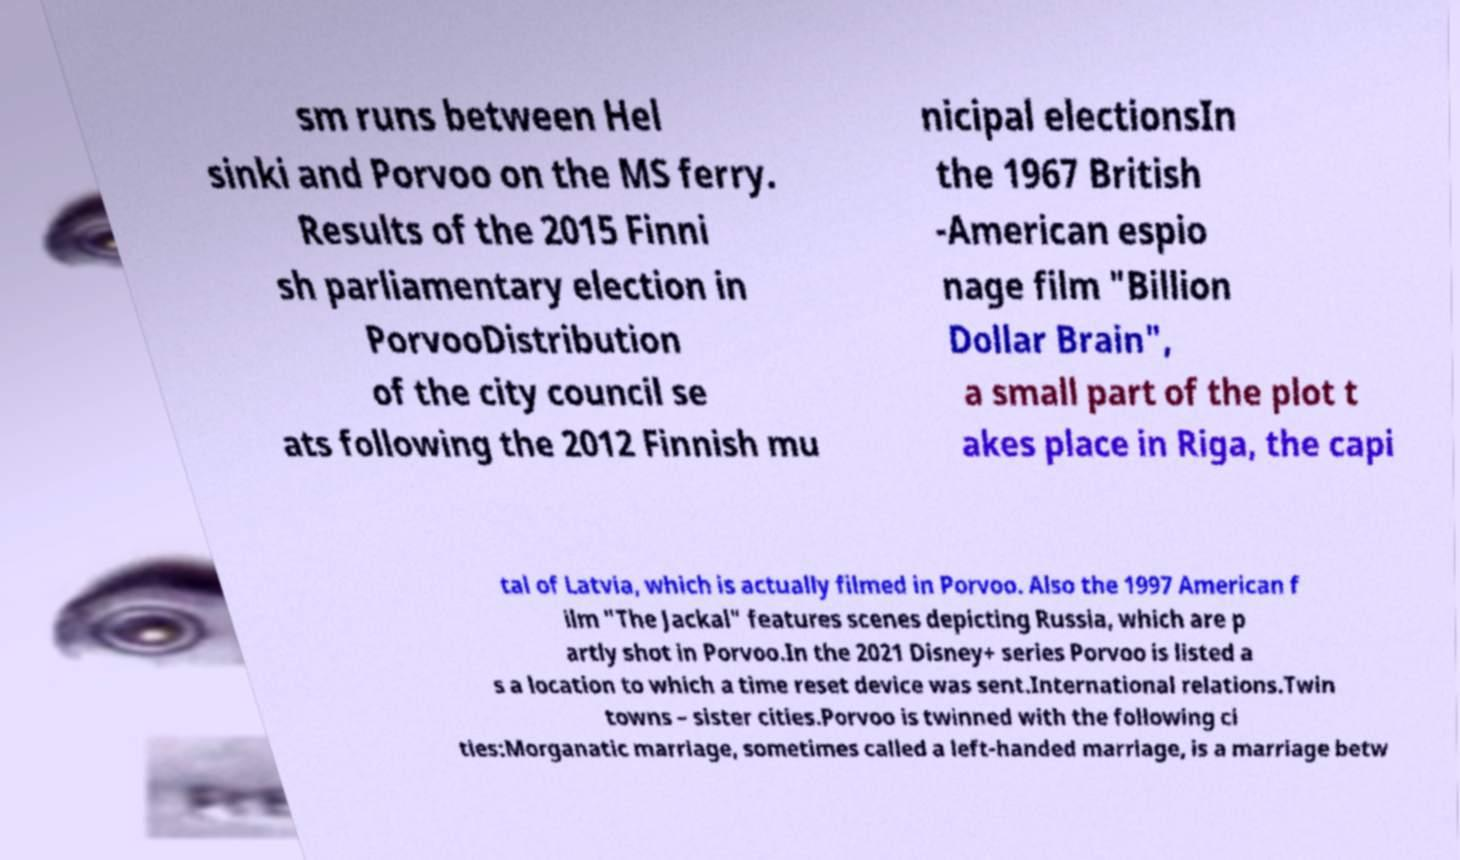I need the written content from this picture converted into text. Can you do that? sm runs between Hel sinki and Porvoo on the MS ferry. Results of the 2015 Finni sh parliamentary election in PorvooDistribution of the city council se ats following the 2012 Finnish mu nicipal electionsIn the 1967 British -American espio nage film "Billion Dollar Brain", a small part of the plot t akes place in Riga, the capi tal of Latvia, which is actually filmed in Porvoo. Also the 1997 American f ilm "The Jackal" features scenes depicting Russia, which are p artly shot in Porvoo.In the 2021 Disney+ series Porvoo is listed a s a location to which a time reset device was sent.International relations.Twin towns – sister cities.Porvoo is twinned with the following ci ties:Morganatic marriage, sometimes called a left-handed marriage, is a marriage betw 